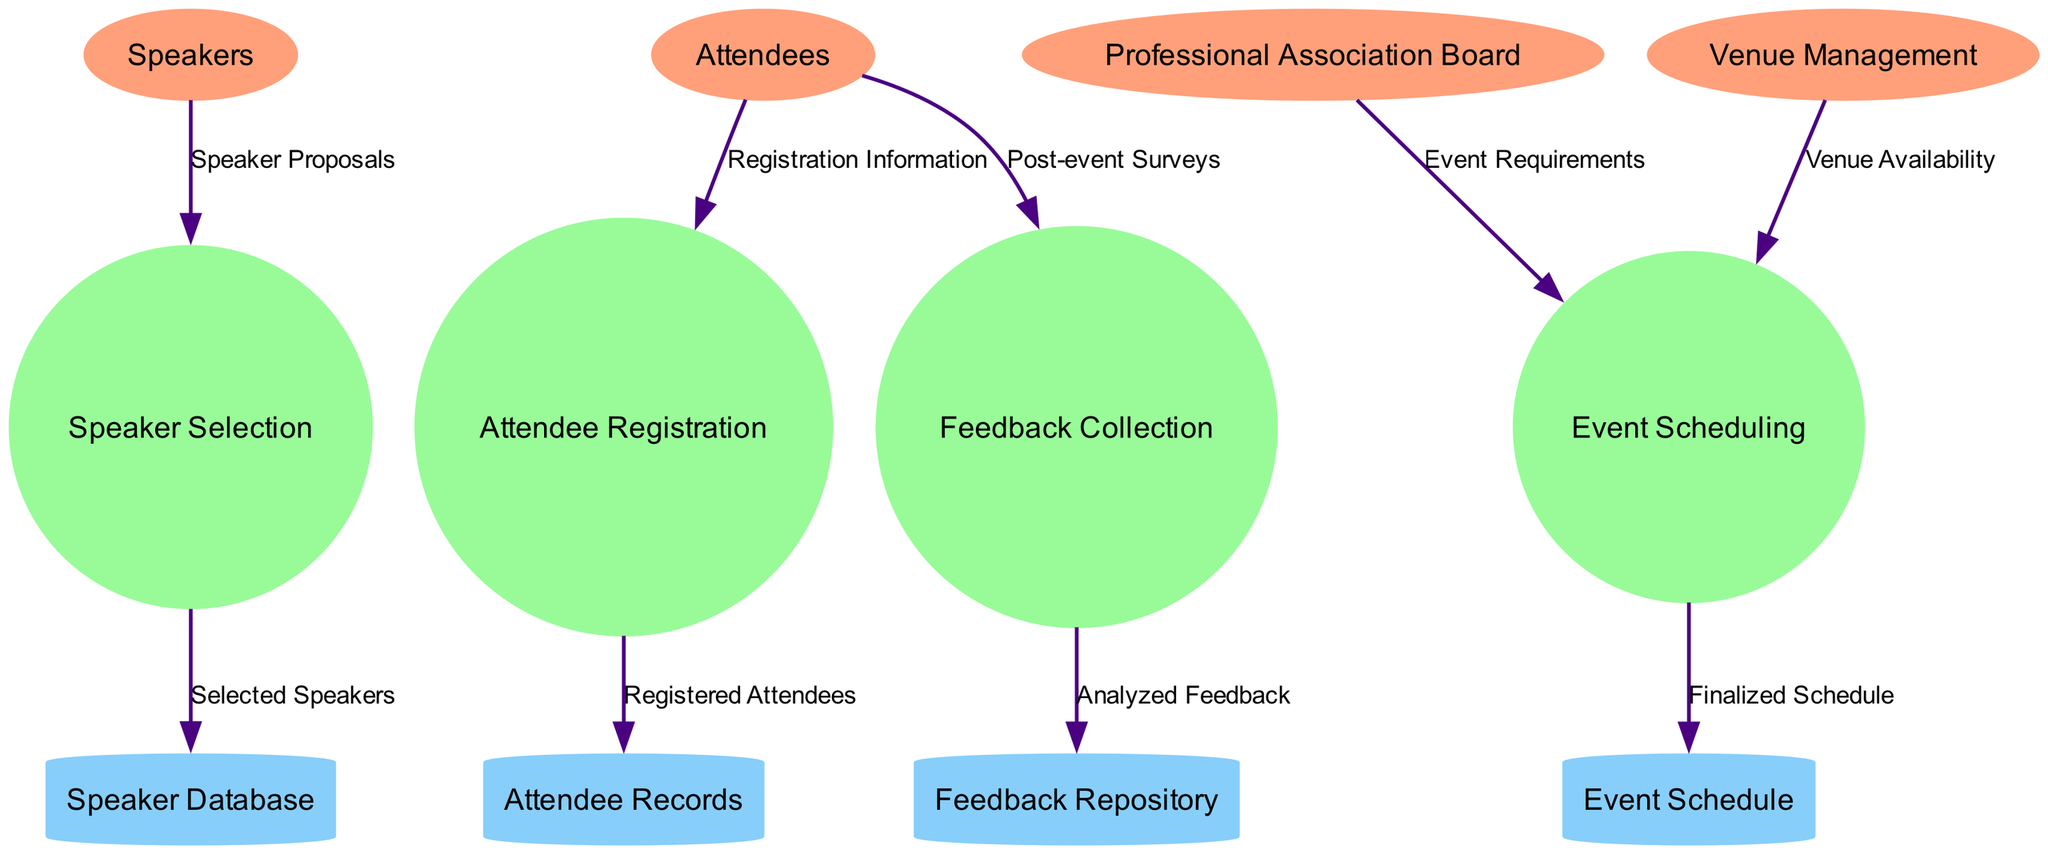What are the external entities in the diagram? The external entities listed in the diagram are: Speakers, Attendees, Professional Association Board, and Venue Management.
Answer: Speakers, Attendees, Professional Association Board, Venue Management How many processes are in the diagram? The diagram shows four processes: Speaker Selection, Attendee Registration, Event Scheduling, and Feedback Collection. Therefore, the total count is four.
Answer: Four What type of data flow is from Attendees to Attendee Registration? The data flow from Attendees to Attendee Registration is labeled "Registration Information". This indicates what type of data is being exchanged between these two nodes.
Answer: Registration Information Which process receives "Event Requirements" as an input? The process "Event Scheduling" receives "Event Requirements" from the Professional Association Board. This shows the dependency of the event scheduling process on the requirements provided by the Board.
Answer: Event Scheduling How many data stores are present in the diagram? There are four data stores in the diagram: Speaker Database, Attendee Records, Event Schedule, and Feedback Repository. Therefore, the total count is four.
Answer: Four What is the output of the "Feedback Collection" process? The output of the "Feedback Collection" process is labeled "Analyzed Feedback", which goes into the Feedback Repository, indicating what data is being stored after processing feedback.
Answer: Analyzed Feedback Which external entity provides "Venue Availability" information? The external entity providing "Venue Availability" is Venue Management. This shows that the scheduling of events is reliant on information from the venue management.
Answer: Venue Management What is the relationship between "Speaker Selection" and "Speaker Database"? The relationship is that "Speaker Selection" contributes "Selected Speakers" to the "Speaker Database", indicating that the selection process directly impacts the database of speakers.
Answer: Selected Speakers How does the process "Attendee Registration" interact with the data store? The process "Attendee Registration" outputs "Registered Attendees" to the data store called "Attendee Records", which stores the information of attendees who successfully registered.
Answer: Attendee Records 